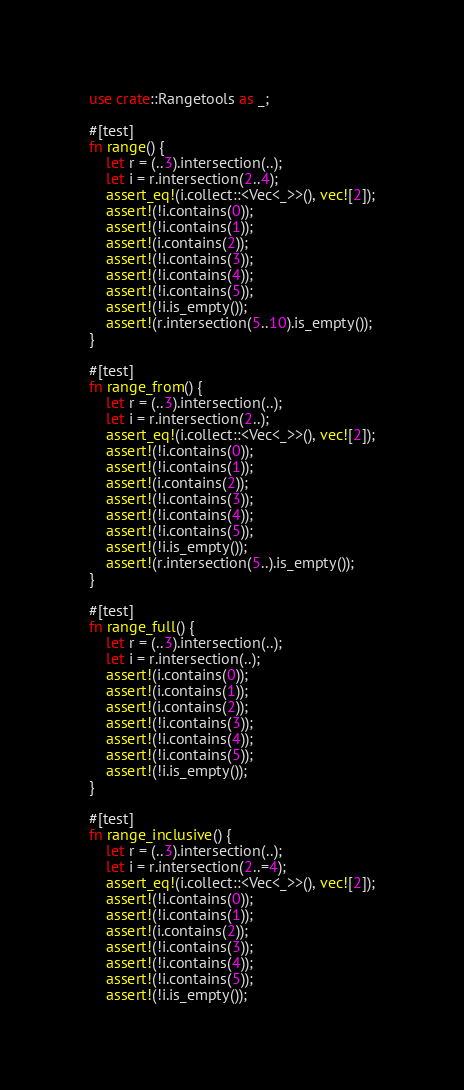Convert code to text. <code><loc_0><loc_0><loc_500><loc_500><_Rust_>use crate::Rangetools as _;

#[test]
fn range() {
    let r = (..3).intersection(..);
    let i = r.intersection(2..4);
    assert_eq!(i.collect::<Vec<_>>(), vec![2]);
    assert!(!i.contains(0));
    assert!(!i.contains(1));
    assert!(i.contains(2));
    assert!(!i.contains(3));
    assert!(!i.contains(4));
    assert!(!i.contains(5));
    assert!(!i.is_empty());
    assert!(r.intersection(5..10).is_empty());
}

#[test]
fn range_from() {
    let r = (..3).intersection(..);
    let i = r.intersection(2..);
    assert_eq!(i.collect::<Vec<_>>(), vec![2]);
    assert!(!i.contains(0));
    assert!(!i.contains(1));
    assert!(i.contains(2));
    assert!(!i.contains(3));
    assert!(!i.contains(4));
    assert!(!i.contains(5));
    assert!(!i.is_empty());
    assert!(r.intersection(5..).is_empty());
}

#[test]
fn range_full() {
    let r = (..3).intersection(..);
    let i = r.intersection(..);
    assert!(i.contains(0));
    assert!(i.contains(1));
    assert!(i.contains(2));
    assert!(!i.contains(3));
    assert!(!i.contains(4));
    assert!(!i.contains(5));
    assert!(!i.is_empty());
}

#[test]
fn range_inclusive() {
    let r = (..3).intersection(..);
    let i = r.intersection(2..=4);
    assert_eq!(i.collect::<Vec<_>>(), vec![2]);
    assert!(!i.contains(0));
    assert!(!i.contains(1));
    assert!(i.contains(2));
    assert!(!i.contains(3));
    assert!(!i.contains(4));
    assert!(!i.contains(5));
    assert!(!i.is_empty());</code> 